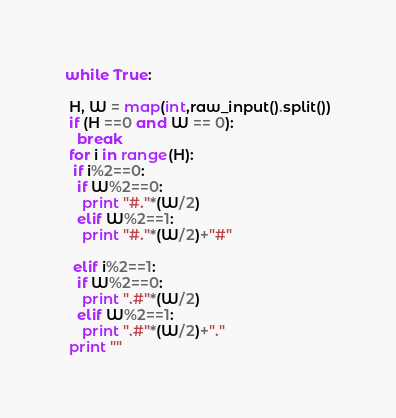Convert code to text. <code><loc_0><loc_0><loc_500><loc_500><_Python_>while True:  

 H, W = map(int,raw_input().split())
 if (H ==0 and W == 0):
   break
 for i in range(H):
  if i%2==0:
   if W%2==0:
    print "#."*(W/2)
   elif W%2==1:
    print "#."*(W/2)+"#"

  elif i%2==1:
   if W%2==0:
    print ".#"*(W/2)
   elif W%2==1:
    print ".#"*(W/2)+"."
 print ""</code> 